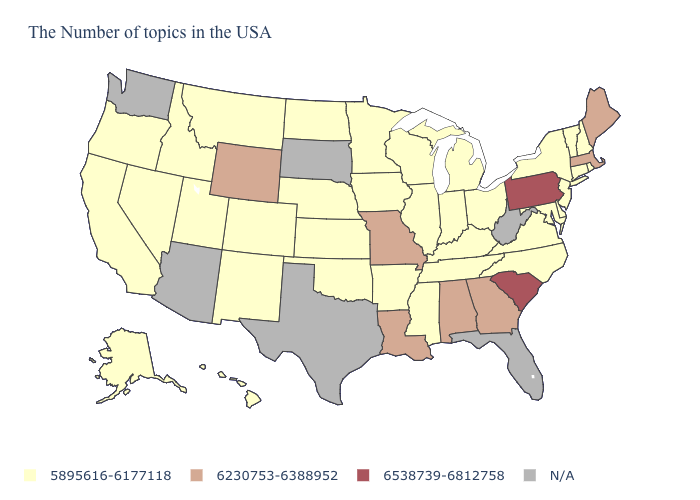Among the states that border Vermont , does New Hampshire have the highest value?
Be succinct. No. What is the value of South Carolina?
Keep it brief. 6538739-6812758. Which states hav the highest value in the West?
Be succinct. Wyoming. What is the highest value in states that border Maryland?
Quick response, please. 6538739-6812758. Name the states that have a value in the range N/A?
Keep it brief. West Virginia, Florida, Texas, South Dakota, Arizona, Washington. Among the states that border Indiana , which have the lowest value?
Quick response, please. Ohio, Michigan, Kentucky, Illinois. Name the states that have a value in the range 6230753-6388952?
Quick response, please. Maine, Massachusetts, Georgia, Alabama, Louisiana, Missouri, Wyoming. What is the value of New Jersey?
Write a very short answer. 5895616-6177118. Which states have the highest value in the USA?
Concise answer only. Pennsylvania, South Carolina. What is the value of West Virginia?
Quick response, please. N/A. What is the value of West Virginia?
Quick response, please. N/A. How many symbols are there in the legend?
Write a very short answer. 4. What is the value of Massachusetts?
Concise answer only. 6230753-6388952. Name the states that have a value in the range N/A?
Concise answer only. West Virginia, Florida, Texas, South Dakota, Arizona, Washington. 